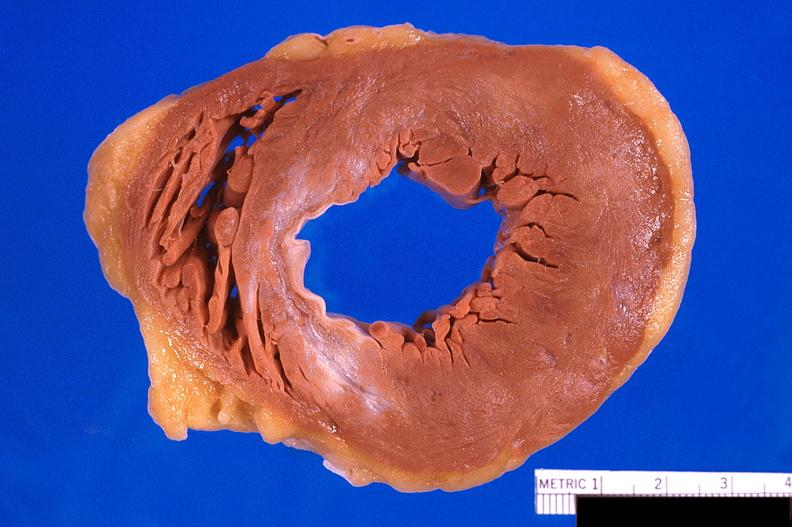what does this image show?
Answer the question using a single word or phrase. Heart 